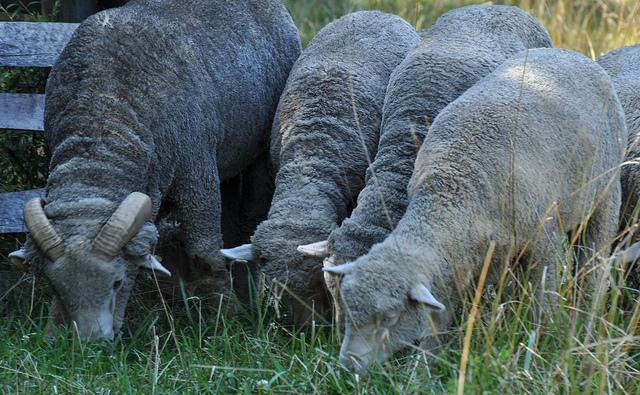A fleece is a kind of hair getting from which mammal? sheep 